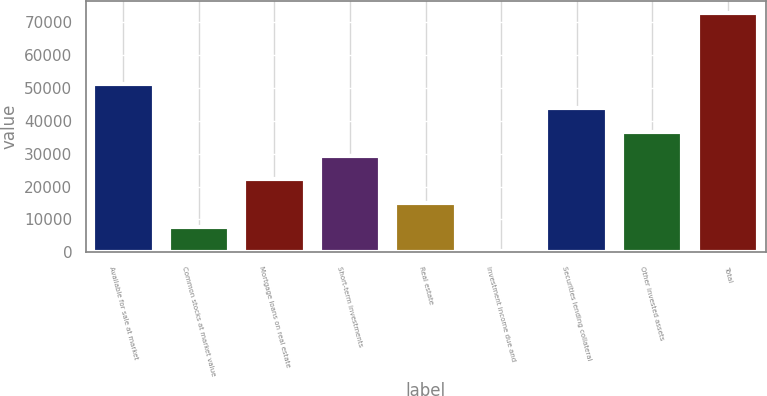Convert chart. <chart><loc_0><loc_0><loc_500><loc_500><bar_chart><fcel>Available for sale at market<fcel>Common stocks at market value<fcel>Mortgage loans on real estate<fcel>Short-term investments<fcel>Real estate<fcel>Investment income due and<fcel>Securities lending collateral<fcel>Other invested assets<fcel>Total<nl><fcel>51154.1<fcel>7652.3<fcel>22152.9<fcel>29403.2<fcel>14902.6<fcel>402<fcel>43903.8<fcel>36653.5<fcel>72905<nl></chart> 